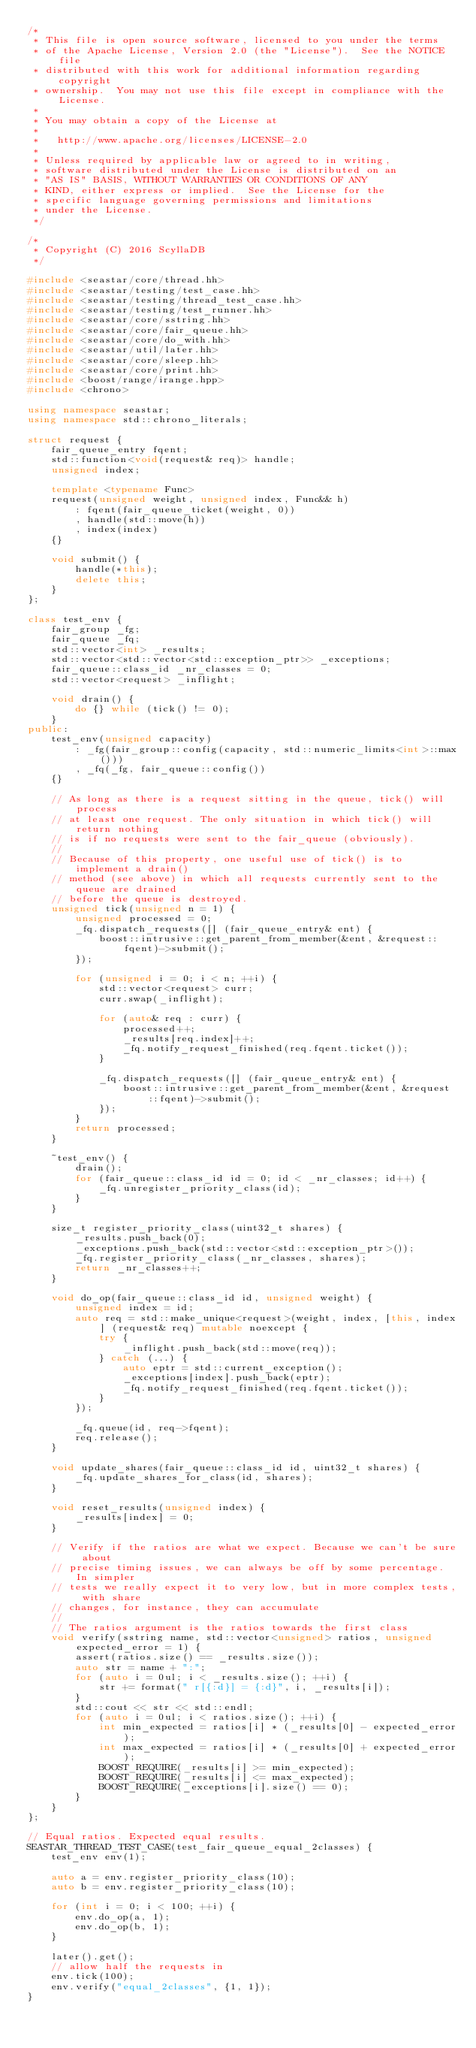<code> <loc_0><loc_0><loc_500><loc_500><_C++_>/*
 * This file is open source software, licensed to you under the terms
 * of the Apache License, Version 2.0 (the "License").  See the NOTICE file
 * distributed with this work for additional information regarding copyright
 * ownership.  You may not use this file except in compliance with the License.
 *
 * You may obtain a copy of the License at
 *
 *   http://www.apache.org/licenses/LICENSE-2.0
 *
 * Unless required by applicable law or agreed to in writing,
 * software distributed under the License is distributed on an
 * "AS IS" BASIS, WITHOUT WARRANTIES OR CONDITIONS OF ANY
 * KIND, either express or implied.  See the License for the
 * specific language governing permissions and limitations
 * under the License.
 */

/*
 * Copyright (C) 2016 ScyllaDB
 */

#include <seastar/core/thread.hh>
#include <seastar/testing/test_case.hh>
#include <seastar/testing/thread_test_case.hh>
#include <seastar/testing/test_runner.hh>
#include <seastar/core/sstring.hh>
#include <seastar/core/fair_queue.hh>
#include <seastar/core/do_with.hh>
#include <seastar/util/later.hh>
#include <seastar/core/sleep.hh>
#include <seastar/core/print.hh>
#include <boost/range/irange.hpp>
#include <chrono>

using namespace seastar;
using namespace std::chrono_literals;

struct request {
    fair_queue_entry fqent;
    std::function<void(request& req)> handle;
    unsigned index;

    template <typename Func>
    request(unsigned weight, unsigned index, Func&& h)
        : fqent(fair_queue_ticket(weight, 0))
        , handle(std::move(h))
        , index(index)
    {}

    void submit() {
        handle(*this);
        delete this;
    }
};

class test_env {
    fair_group _fg;
    fair_queue _fq;
    std::vector<int> _results;
    std::vector<std::vector<std::exception_ptr>> _exceptions;
    fair_queue::class_id _nr_classes = 0;
    std::vector<request> _inflight;

    void drain() {
        do {} while (tick() != 0);
    }
public:
    test_env(unsigned capacity)
        : _fg(fair_group::config(capacity, std::numeric_limits<int>::max()))
        , _fq(_fg, fair_queue::config())
    {}

    // As long as there is a request sitting in the queue, tick() will process
    // at least one request. The only situation in which tick() will return nothing
    // is if no requests were sent to the fair_queue (obviously).
    //
    // Because of this property, one useful use of tick() is to implement a drain()
    // method (see above) in which all requests currently sent to the queue are drained
    // before the queue is destroyed.
    unsigned tick(unsigned n = 1) {
        unsigned processed = 0;
        _fq.dispatch_requests([] (fair_queue_entry& ent) {
            boost::intrusive::get_parent_from_member(&ent, &request::fqent)->submit();
        });

        for (unsigned i = 0; i < n; ++i) {
            std::vector<request> curr;
            curr.swap(_inflight);

            for (auto& req : curr) {
                processed++;
                _results[req.index]++;
                _fq.notify_request_finished(req.fqent.ticket());
            }

            _fq.dispatch_requests([] (fair_queue_entry& ent) {
                boost::intrusive::get_parent_from_member(&ent, &request::fqent)->submit();
            });
        }
        return processed;
    }

    ~test_env() {
        drain();
        for (fair_queue::class_id id = 0; id < _nr_classes; id++) {
            _fq.unregister_priority_class(id);
        }
    }

    size_t register_priority_class(uint32_t shares) {
        _results.push_back(0);
        _exceptions.push_back(std::vector<std::exception_ptr>());
        _fq.register_priority_class(_nr_classes, shares);
        return _nr_classes++;
    }

    void do_op(fair_queue::class_id id, unsigned weight) {
        unsigned index = id;
        auto req = std::make_unique<request>(weight, index, [this, index] (request& req) mutable noexcept {
            try {
                _inflight.push_back(std::move(req));
            } catch (...) {
                auto eptr = std::current_exception();
                _exceptions[index].push_back(eptr);
                _fq.notify_request_finished(req.fqent.ticket());
            }
        });

        _fq.queue(id, req->fqent);
        req.release();
    }

    void update_shares(fair_queue::class_id id, uint32_t shares) {
        _fq.update_shares_for_class(id, shares);
    }

    void reset_results(unsigned index) {
        _results[index] = 0;
    }

    // Verify if the ratios are what we expect. Because we can't be sure about
    // precise timing issues, we can always be off by some percentage. In simpler
    // tests we really expect it to very low, but in more complex tests, with share
    // changes, for instance, they can accumulate
    //
    // The ratios argument is the ratios towards the first class
    void verify(sstring name, std::vector<unsigned> ratios, unsigned expected_error = 1) {
        assert(ratios.size() == _results.size());
        auto str = name + ":";
        for (auto i = 0ul; i < _results.size(); ++i) {
            str += format(" r[{:d}] = {:d}", i, _results[i]);
        }
        std::cout << str << std::endl;
        for (auto i = 0ul; i < ratios.size(); ++i) {
            int min_expected = ratios[i] * (_results[0] - expected_error);
            int max_expected = ratios[i] * (_results[0] + expected_error);
            BOOST_REQUIRE(_results[i] >= min_expected);
            BOOST_REQUIRE(_results[i] <= max_expected);
            BOOST_REQUIRE(_exceptions[i].size() == 0);
        }
    }
};

// Equal ratios. Expected equal results.
SEASTAR_THREAD_TEST_CASE(test_fair_queue_equal_2classes) {
    test_env env(1);

    auto a = env.register_priority_class(10);
    auto b = env.register_priority_class(10);

    for (int i = 0; i < 100; ++i) {
        env.do_op(a, 1);
        env.do_op(b, 1);
    }

    later().get();
    // allow half the requests in
    env.tick(100);
    env.verify("equal_2classes", {1, 1});
}
</code> 